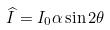Convert formula to latex. <formula><loc_0><loc_0><loc_500><loc_500>\widehat { I } = I _ { 0 } \alpha \sin 2 \theta</formula> 